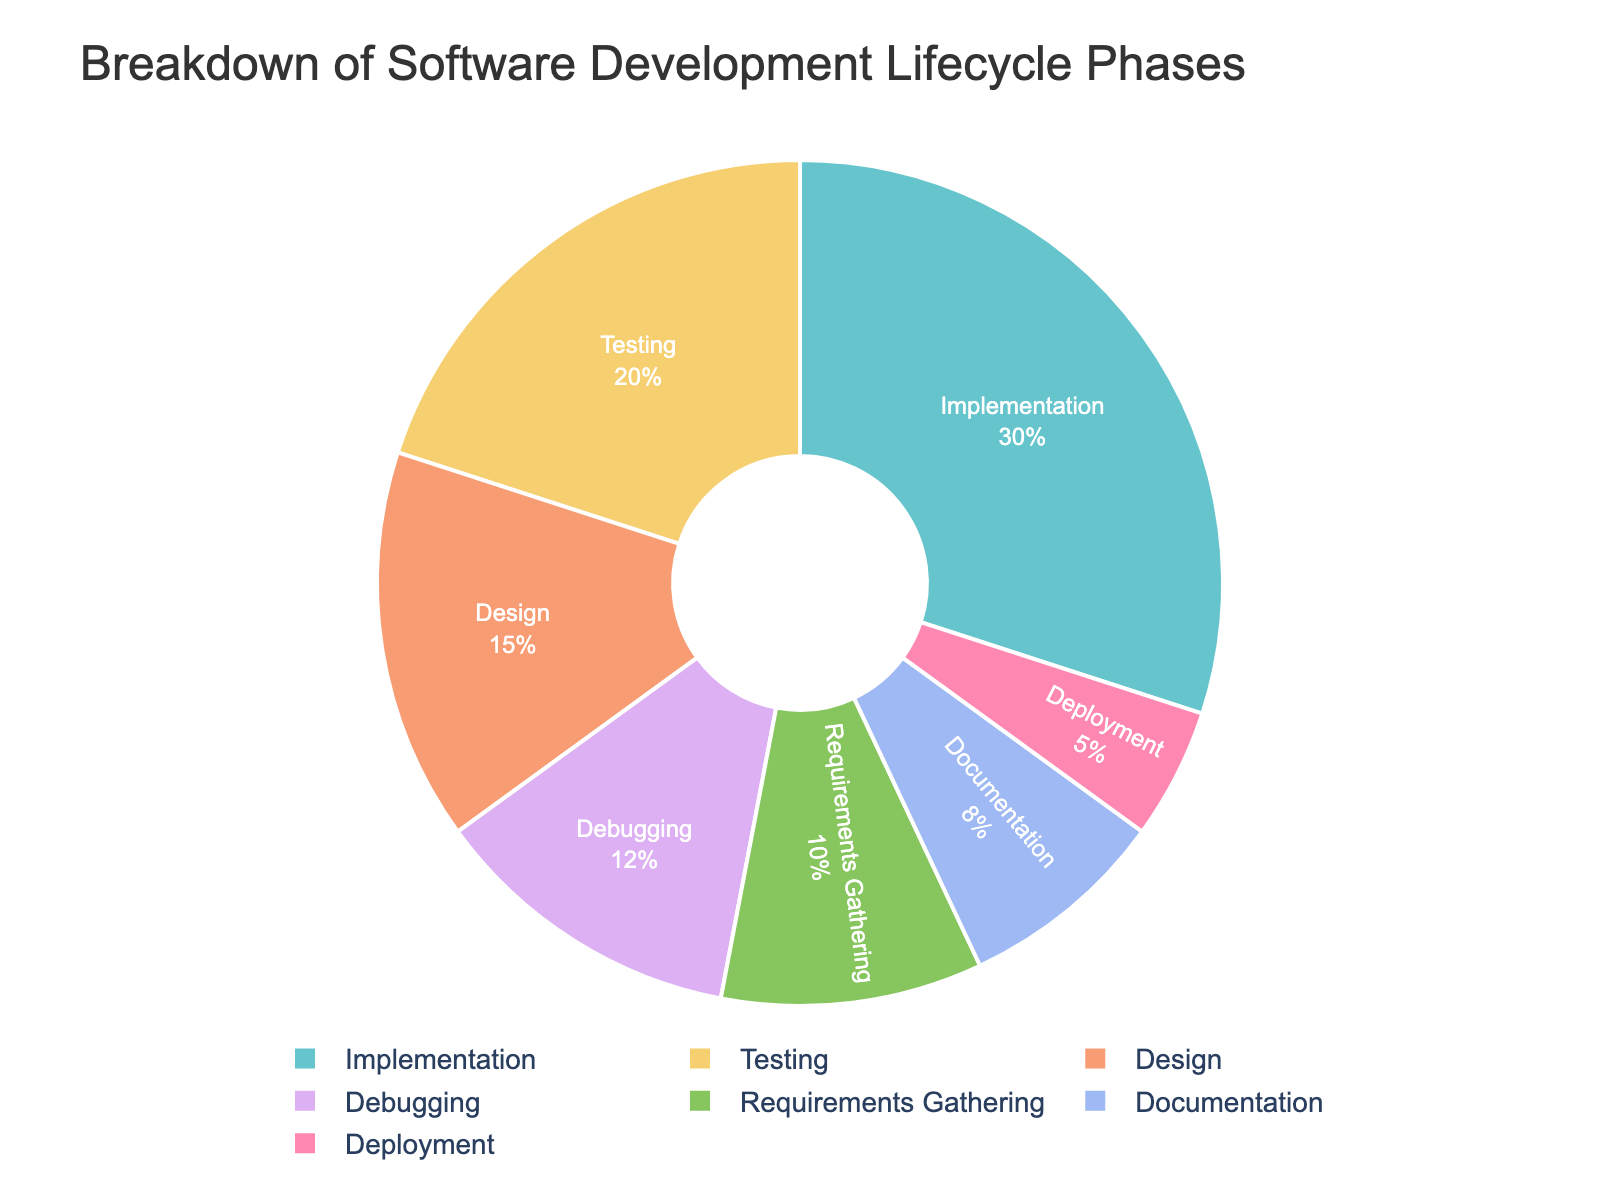Which phase has the highest percentage? To find the phase with the highest percentage, look at the segments in the pie chart and identify which one is the largest. Implementation accounts for 30%, which is more than any other phase.
Answer: Implementation Which two phases combined take up the most time? By examining the pie chart, we see that Implementation and Testing have the two highest percentages. Adding them together (30% + 20% = 50%), they form the largest combined portion.
Answer: Implementation and Testing What is the total percentage of time spent on Debugging and Documentation? Add the percentages of Debugging and Documentation from the pie chart: 12% + 8% = 20%.
Answer: 20% Which phase takes up less time: Requirements Gathering or Deployment? Compare the segments corresponding to Requirements Gathering (10%) and Deployment (5%) on the pie chart. Deployment takes up less time.
Answer: Deployment Are there any phases that take up an equal amount of time? From the pie chart, look for any segments with the same percentage. There are no phases with equal percentages; each has a unique percentage.
Answer: No What is the difference in percentage between Testing and Design? Subtract the percentage of Design from Testing: 20% (Testing) - 15% (Design) = 5%.
Answer: 5% Which phase has the second largest percentage after Implementation? Identify the second largest segment after Implementation (30%) in the pie chart. Testing is next with 20%.
Answer: Testing What percentage of time is spent on phases other than Implementation and Testing? Subtract the combined percentage of Implementation and Testing (30% + 20% = 50%) from 100%: 100% - 50% = 50%.
Answer: 50% What is the ratio of time spent on Requirements Gathering to that on Deployment? Divide the percentage of Requirements Gathering by Deployment from the pie chart: 10% (Requirements Gathering) / 5% (Deployment) = 2.
Answer: 2 How much more time is spent on Debugging compared to Deployment? Subtract the percentage of Deployment from Debugging: 12% (Debugging) - 5% (Deployment) = 7%.
Answer: 7% 